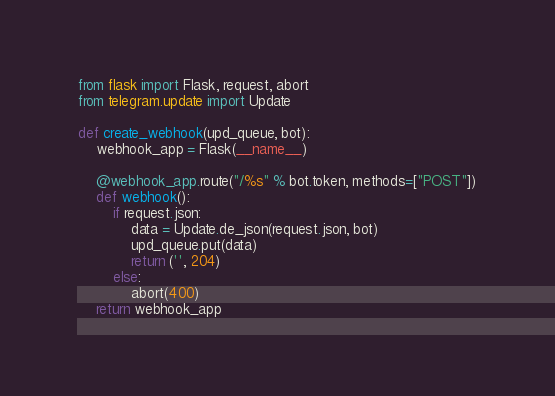Convert code to text. <code><loc_0><loc_0><loc_500><loc_500><_Python_>from flask import Flask, request, abort
from telegram.update import Update

def create_webhook(upd_queue, bot):
    webhook_app = Flask(__name__)

    @webhook_app.route("/%s" % bot.token, methods=["POST"])
    def webhook():
        if request.json:
            data = Update.de_json(request.json, bot)
            upd_queue.put(data)
            return ('', 204)
        else:
            abort(400)
    return webhook_app
</code> 